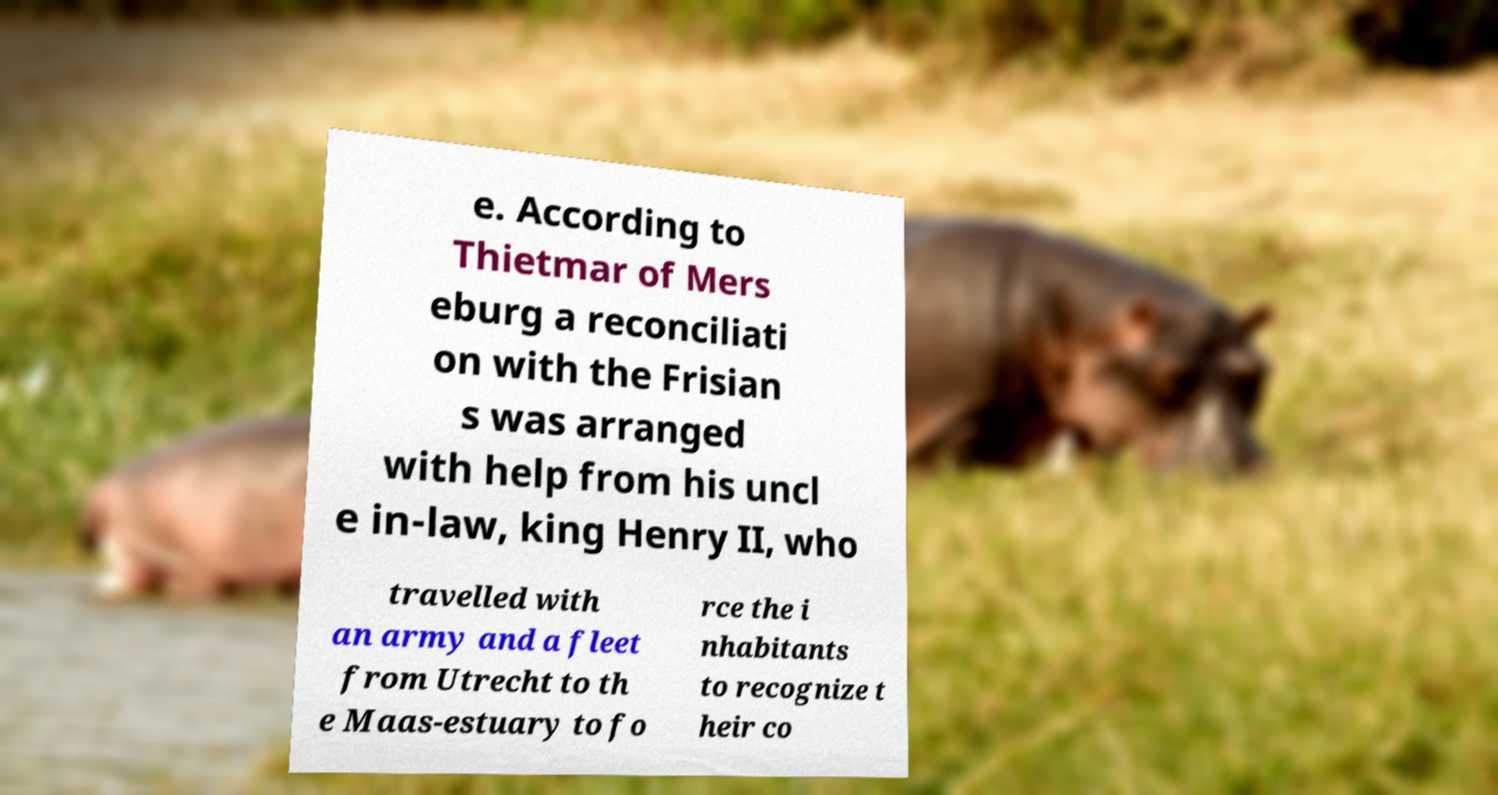What messages or text are displayed in this image? I need them in a readable, typed format. e. According to Thietmar of Mers eburg a reconciliati on with the Frisian s was arranged with help from his uncl e in-law, king Henry II, who travelled with an army and a fleet from Utrecht to th e Maas-estuary to fo rce the i nhabitants to recognize t heir co 